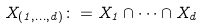Convert formula to latex. <formula><loc_0><loc_0><loc_500><loc_500>X _ { ( 1 , \dots , d ) } \colon = X _ { 1 } \cap \dots \cap X _ { d }</formula> 